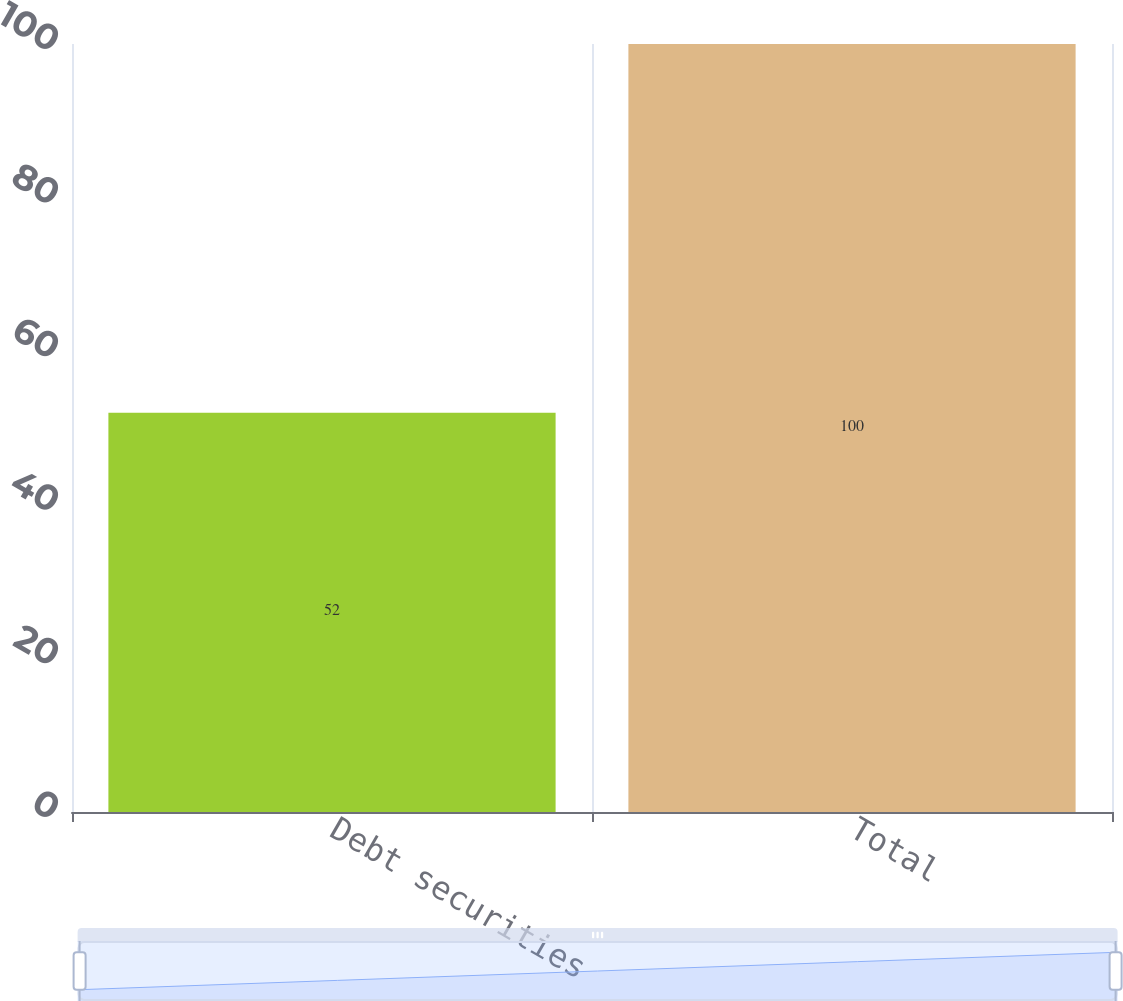Convert chart. <chart><loc_0><loc_0><loc_500><loc_500><bar_chart><fcel>Debt securities<fcel>Total<nl><fcel>52<fcel>100<nl></chart> 